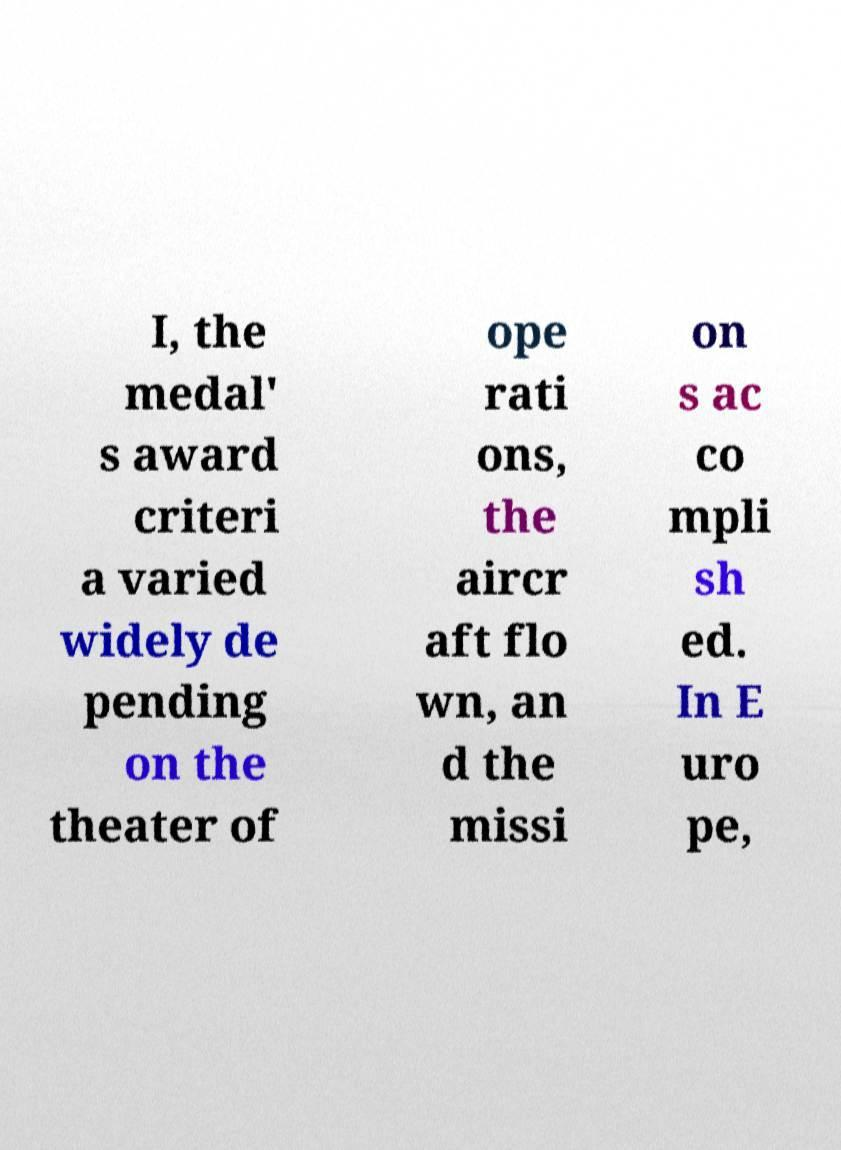There's text embedded in this image that I need extracted. Can you transcribe it verbatim? I, the medal' s award criteri a varied widely de pending on the theater of ope rati ons, the aircr aft flo wn, an d the missi on s ac co mpli sh ed. In E uro pe, 